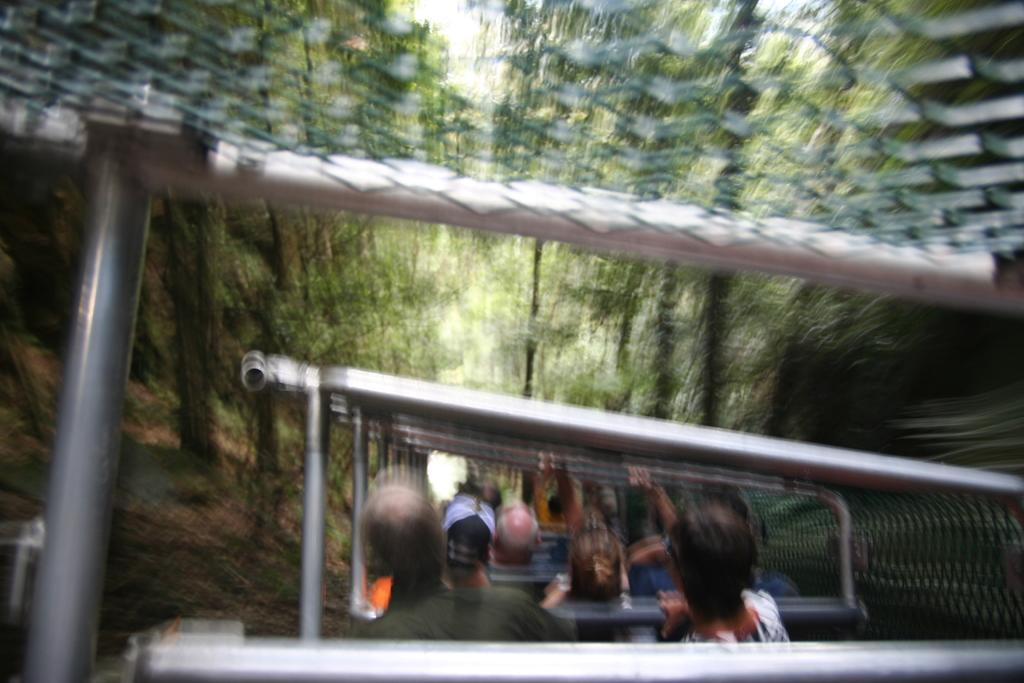What is the primary feature of the landscape in the image? There are many trees in the image. What activity involving a vehicle can be seen in the image? There are people riding in a vehicle in the image. What type of pen is being used to draw on the stage in the image? There is no stage or pen present in the image; it features many trees and people riding in a vehicle. 